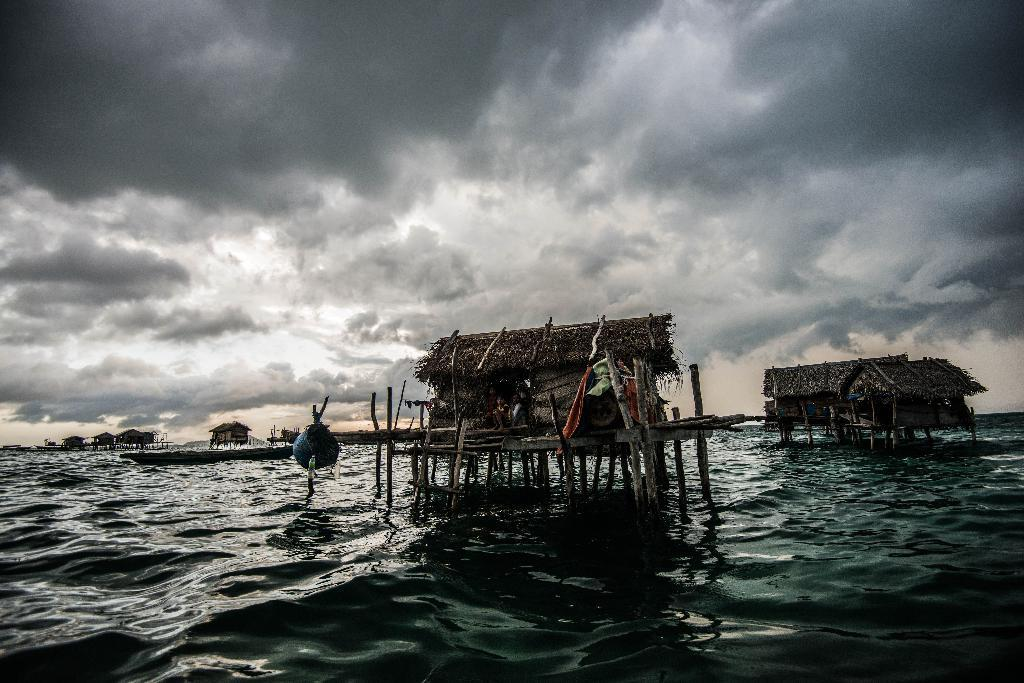What is the main element present in the image? There is water in the image. What structures can be seen in the water? There are huts in the middle of the water. How would you describe the sky in the background? The sky in the background has a white and gray color. How many clover leaves can be seen growing near the huts? There are no clover leaves present in the image. What type of lipstick is the person wearing in the image? There are no people or lipstick visible in the image. 